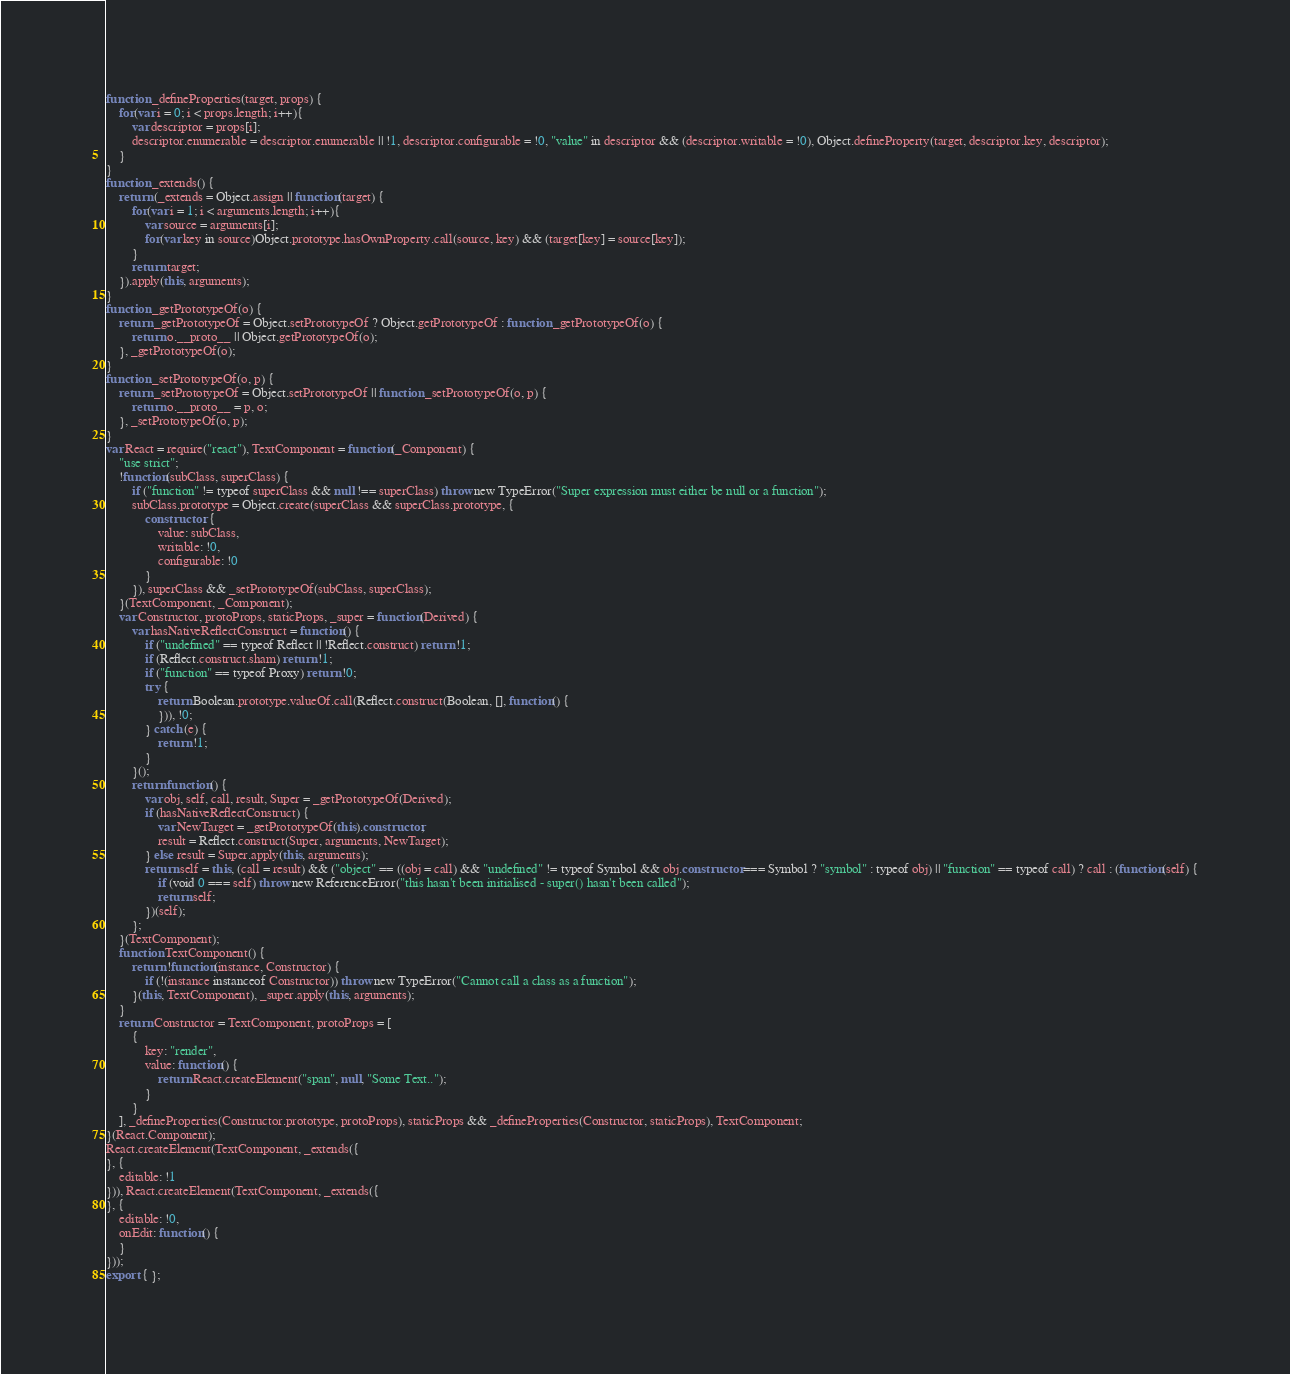<code> <loc_0><loc_0><loc_500><loc_500><_JavaScript_>function _defineProperties(target, props) {
    for(var i = 0; i < props.length; i++){
        var descriptor = props[i];
        descriptor.enumerable = descriptor.enumerable || !1, descriptor.configurable = !0, "value" in descriptor && (descriptor.writable = !0), Object.defineProperty(target, descriptor.key, descriptor);
    }
}
function _extends() {
    return (_extends = Object.assign || function(target) {
        for(var i = 1; i < arguments.length; i++){
            var source = arguments[i];
            for(var key in source)Object.prototype.hasOwnProperty.call(source, key) && (target[key] = source[key]);
        }
        return target;
    }).apply(this, arguments);
}
function _getPrototypeOf(o) {
    return _getPrototypeOf = Object.setPrototypeOf ? Object.getPrototypeOf : function _getPrototypeOf(o) {
        return o.__proto__ || Object.getPrototypeOf(o);
    }, _getPrototypeOf(o);
}
function _setPrototypeOf(o, p) {
    return _setPrototypeOf = Object.setPrototypeOf || function _setPrototypeOf(o, p) {
        return o.__proto__ = p, o;
    }, _setPrototypeOf(o, p);
}
var React = require("react"), TextComponent = function(_Component) {
    "use strict";
    !function(subClass, superClass) {
        if ("function" != typeof superClass && null !== superClass) throw new TypeError("Super expression must either be null or a function");
        subClass.prototype = Object.create(superClass && superClass.prototype, {
            constructor: {
                value: subClass,
                writable: !0,
                configurable: !0
            }
        }), superClass && _setPrototypeOf(subClass, superClass);
    }(TextComponent, _Component);
    var Constructor, protoProps, staticProps, _super = function(Derived) {
        var hasNativeReflectConstruct = function() {
            if ("undefined" == typeof Reflect || !Reflect.construct) return !1;
            if (Reflect.construct.sham) return !1;
            if ("function" == typeof Proxy) return !0;
            try {
                return Boolean.prototype.valueOf.call(Reflect.construct(Boolean, [], function() {
                })), !0;
            } catch (e) {
                return !1;
            }
        }();
        return function() {
            var obj, self, call, result, Super = _getPrototypeOf(Derived);
            if (hasNativeReflectConstruct) {
                var NewTarget = _getPrototypeOf(this).constructor;
                result = Reflect.construct(Super, arguments, NewTarget);
            } else result = Super.apply(this, arguments);
            return self = this, (call = result) && ("object" == ((obj = call) && "undefined" != typeof Symbol && obj.constructor === Symbol ? "symbol" : typeof obj) || "function" == typeof call) ? call : (function(self) {
                if (void 0 === self) throw new ReferenceError("this hasn't been initialised - super() hasn't been called");
                return self;
            })(self);
        };
    }(TextComponent);
    function TextComponent() {
        return !function(instance, Constructor) {
            if (!(instance instanceof Constructor)) throw new TypeError("Cannot call a class as a function");
        }(this, TextComponent), _super.apply(this, arguments);
    }
    return Constructor = TextComponent, protoProps = [
        {
            key: "render",
            value: function() {
                return React.createElement("span", null, "Some Text..");
            }
        }
    ], _defineProperties(Constructor.prototype, protoProps), staticProps && _defineProperties(Constructor, staticProps), TextComponent;
}(React.Component);
React.createElement(TextComponent, _extends({
}, {
    editable: !1
})), React.createElement(TextComponent, _extends({
}, {
    editable: !0,
    onEdit: function() {
    }
}));
export { };
</code> 